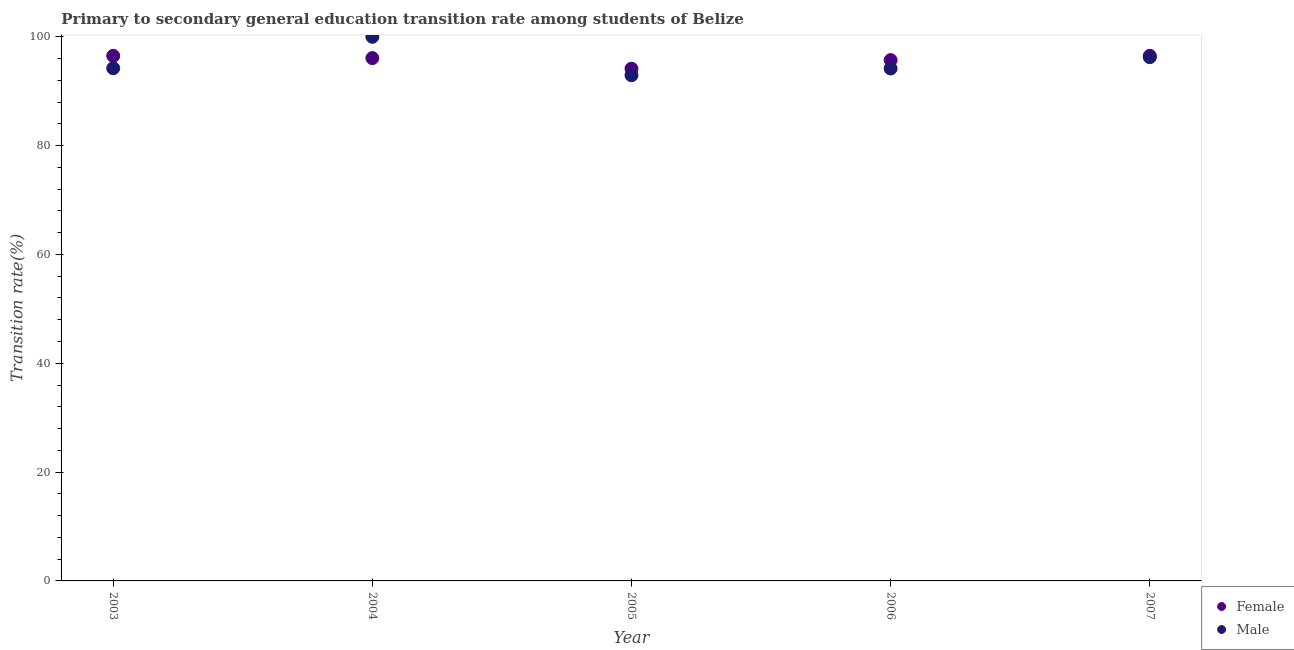How many different coloured dotlines are there?
Your answer should be very brief. 2. What is the transition rate among male students in 2003?
Your response must be concise. 94.22. Across all years, what is the maximum transition rate among female students?
Offer a very short reply. 96.51. Across all years, what is the minimum transition rate among male students?
Offer a very short reply. 92.93. In which year was the transition rate among male students minimum?
Your answer should be very brief. 2005. What is the total transition rate among female students in the graph?
Give a very brief answer. 478.94. What is the difference between the transition rate among female students in 2003 and that in 2005?
Your response must be concise. 2.37. What is the difference between the transition rate among male students in 2003 and the transition rate among female students in 2006?
Your response must be concise. -1.5. What is the average transition rate among male students per year?
Keep it short and to the point. 95.52. In the year 2004, what is the difference between the transition rate among female students and transition rate among male students?
Keep it short and to the point. -3.92. What is the ratio of the transition rate among female students in 2003 to that in 2004?
Provide a succinct answer. 1. Is the transition rate among male students in 2003 less than that in 2007?
Offer a very short reply. Yes. What is the difference between the highest and the second highest transition rate among male students?
Provide a short and direct response. 3.75. What is the difference between the highest and the lowest transition rate among female students?
Ensure brevity in your answer.  2.37. In how many years, is the transition rate among male students greater than the average transition rate among male students taken over all years?
Give a very brief answer. 2. Is the transition rate among male students strictly less than the transition rate among female students over the years?
Make the answer very short. No. How many dotlines are there?
Give a very brief answer. 2. How many years are there in the graph?
Keep it short and to the point. 5. What is the difference between two consecutive major ticks on the Y-axis?
Ensure brevity in your answer.  20. Does the graph contain any zero values?
Your response must be concise. No. How are the legend labels stacked?
Your response must be concise. Vertical. What is the title of the graph?
Your answer should be compact. Primary to secondary general education transition rate among students of Belize. Does "Passenger Transport Items" appear as one of the legend labels in the graph?
Ensure brevity in your answer.  No. What is the label or title of the X-axis?
Provide a short and direct response. Year. What is the label or title of the Y-axis?
Offer a very short reply. Transition rate(%). What is the Transition rate(%) in Female in 2003?
Your response must be concise. 96.5. What is the Transition rate(%) in Male in 2003?
Give a very brief answer. 94.22. What is the Transition rate(%) in Female in 2004?
Your response must be concise. 96.08. What is the Transition rate(%) of Female in 2005?
Your response must be concise. 94.13. What is the Transition rate(%) of Male in 2005?
Keep it short and to the point. 92.93. What is the Transition rate(%) of Female in 2006?
Provide a succinct answer. 95.72. What is the Transition rate(%) of Male in 2006?
Provide a short and direct response. 94.17. What is the Transition rate(%) in Female in 2007?
Your answer should be compact. 96.51. What is the Transition rate(%) of Male in 2007?
Offer a very short reply. 96.25. Across all years, what is the maximum Transition rate(%) of Female?
Your answer should be very brief. 96.51. Across all years, what is the maximum Transition rate(%) in Male?
Your answer should be very brief. 100. Across all years, what is the minimum Transition rate(%) of Female?
Your response must be concise. 94.13. Across all years, what is the minimum Transition rate(%) of Male?
Offer a terse response. 92.93. What is the total Transition rate(%) in Female in the graph?
Provide a short and direct response. 478.94. What is the total Transition rate(%) of Male in the graph?
Offer a terse response. 477.58. What is the difference between the Transition rate(%) of Female in 2003 and that in 2004?
Give a very brief answer. 0.42. What is the difference between the Transition rate(%) in Male in 2003 and that in 2004?
Provide a short and direct response. -5.78. What is the difference between the Transition rate(%) in Female in 2003 and that in 2005?
Your answer should be very brief. 2.37. What is the difference between the Transition rate(%) in Male in 2003 and that in 2005?
Your answer should be compact. 1.29. What is the difference between the Transition rate(%) in Female in 2003 and that in 2006?
Your answer should be very brief. 0.78. What is the difference between the Transition rate(%) of Male in 2003 and that in 2006?
Make the answer very short. 0.05. What is the difference between the Transition rate(%) in Female in 2003 and that in 2007?
Give a very brief answer. -0.01. What is the difference between the Transition rate(%) in Male in 2003 and that in 2007?
Provide a succinct answer. -2.03. What is the difference between the Transition rate(%) in Female in 2004 and that in 2005?
Give a very brief answer. 1.95. What is the difference between the Transition rate(%) in Male in 2004 and that in 2005?
Your answer should be compact. 7.07. What is the difference between the Transition rate(%) of Female in 2004 and that in 2006?
Offer a very short reply. 0.37. What is the difference between the Transition rate(%) in Male in 2004 and that in 2006?
Keep it short and to the point. 5.83. What is the difference between the Transition rate(%) of Female in 2004 and that in 2007?
Offer a very short reply. -0.42. What is the difference between the Transition rate(%) of Male in 2004 and that in 2007?
Provide a succinct answer. 3.75. What is the difference between the Transition rate(%) of Female in 2005 and that in 2006?
Offer a very short reply. -1.58. What is the difference between the Transition rate(%) in Male in 2005 and that in 2006?
Provide a succinct answer. -1.24. What is the difference between the Transition rate(%) of Female in 2005 and that in 2007?
Provide a succinct answer. -2.37. What is the difference between the Transition rate(%) of Male in 2005 and that in 2007?
Your response must be concise. -3.32. What is the difference between the Transition rate(%) of Female in 2006 and that in 2007?
Your answer should be compact. -0.79. What is the difference between the Transition rate(%) in Male in 2006 and that in 2007?
Your response must be concise. -2.08. What is the difference between the Transition rate(%) of Female in 2003 and the Transition rate(%) of Male in 2004?
Give a very brief answer. -3.5. What is the difference between the Transition rate(%) in Female in 2003 and the Transition rate(%) in Male in 2005?
Offer a very short reply. 3.57. What is the difference between the Transition rate(%) of Female in 2003 and the Transition rate(%) of Male in 2006?
Offer a very short reply. 2.33. What is the difference between the Transition rate(%) of Female in 2003 and the Transition rate(%) of Male in 2007?
Your answer should be compact. 0.25. What is the difference between the Transition rate(%) in Female in 2004 and the Transition rate(%) in Male in 2005?
Provide a short and direct response. 3.15. What is the difference between the Transition rate(%) of Female in 2004 and the Transition rate(%) of Male in 2006?
Give a very brief answer. 1.91. What is the difference between the Transition rate(%) in Female in 2004 and the Transition rate(%) in Male in 2007?
Offer a very short reply. -0.17. What is the difference between the Transition rate(%) in Female in 2005 and the Transition rate(%) in Male in 2006?
Your response must be concise. -0.04. What is the difference between the Transition rate(%) of Female in 2005 and the Transition rate(%) of Male in 2007?
Provide a succinct answer. -2.12. What is the difference between the Transition rate(%) of Female in 2006 and the Transition rate(%) of Male in 2007?
Ensure brevity in your answer.  -0.54. What is the average Transition rate(%) in Female per year?
Your response must be concise. 95.79. What is the average Transition rate(%) in Male per year?
Provide a succinct answer. 95.52. In the year 2003, what is the difference between the Transition rate(%) of Female and Transition rate(%) of Male?
Keep it short and to the point. 2.28. In the year 2004, what is the difference between the Transition rate(%) of Female and Transition rate(%) of Male?
Provide a succinct answer. -3.92. In the year 2005, what is the difference between the Transition rate(%) of Female and Transition rate(%) of Male?
Your answer should be very brief. 1.2. In the year 2006, what is the difference between the Transition rate(%) of Female and Transition rate(%) of Male?
Your answer should be very brief. 1.54. In the year 2007, what is the difference between the Transition rate(%) of Female and Transition rate(%) of Male?
Your answer should be compact. 0.25. What is the ratio of the Transition rate(%) of Female in 2003 to that in 2004?
Offer a terse response. 1. What is the ratio of the Transition rate(%) in Male in 2003 to that in 2004?
Keep it short and to the point. 0.94. What is the ratio of the Transition rate(%) in Female in 2003 to that in 2005?
Your response must be concise. 1.03. What is the ratio of the Transition rate(%) of Male in 2003 to that in 2005?
Your answer should be very brief. 1.01. What is the ratio of the Transition rate(%) in Female in 2003 to that in 2006?
Keep it short and to the point. 1.01. What is the ratio of the Transition rate(%) of Male in 2003 to that in 2006?
Your answer should be compact. 1. What is the ratio of the Transition rate(%) of Male in 2003 to that in 2007?
Offer a very short reply. 0.98. What is the ratio of the Transition rate(%) in Female in 2004 to that in 2005?
Your answer should be compact. 1.02. What is the ratio of the Transition rate(%) of Male in 2004 to that in 2005?
Give a very brief answer. 1.08. What is the ratio of the Transition rate(%) of Male in 2004 to that in 2006?
Ensure brevity in your answer.  1.06. What is the ratio of the Transition rate(%) of Female in 2004 to that in 2007?
Provide a succinct answer. 1. What is the ratio of the Transition rate(%) of Male in 2004 to that in 2007?
Provide a succinct answer. 1.04. What is the ratio of the Transition rate(%) in Female in 2005 to that in 2006?
Your answer should be very brief. 0.98. What is the ratio of the Transition rate(%) in Female in 2005 to that in 2007?
Offer a very short reply. 0.98. What is the ratio of the Transition rate(%) of Male in 2005 to that in 2007?
Your answer should be very brief. 0.97. What is the ratio of the Transition rate(%) of Female in 2006 to that in 2007?
Provide a short and direct response. 0.99. What is the ratio of the Transition rate(%) of Male in 2006 to that in 2007?
Your response must be concise. 0.98. What is the difference between the highest and the second highest Transition rate(%) of Female?
Your answer should be compact. 0.01. What is the difference between the highest and the second highest Transition rate(%) in Male?
Your response must be concise. 3.75. What is the difference between the highest and the lowest Transition rate(%) in Female?
Your answer should be compact. 2.37. What is the difference between the highest and the lowest Transition rate(%) of Male?
Keep it short and to the point. 7.07. 